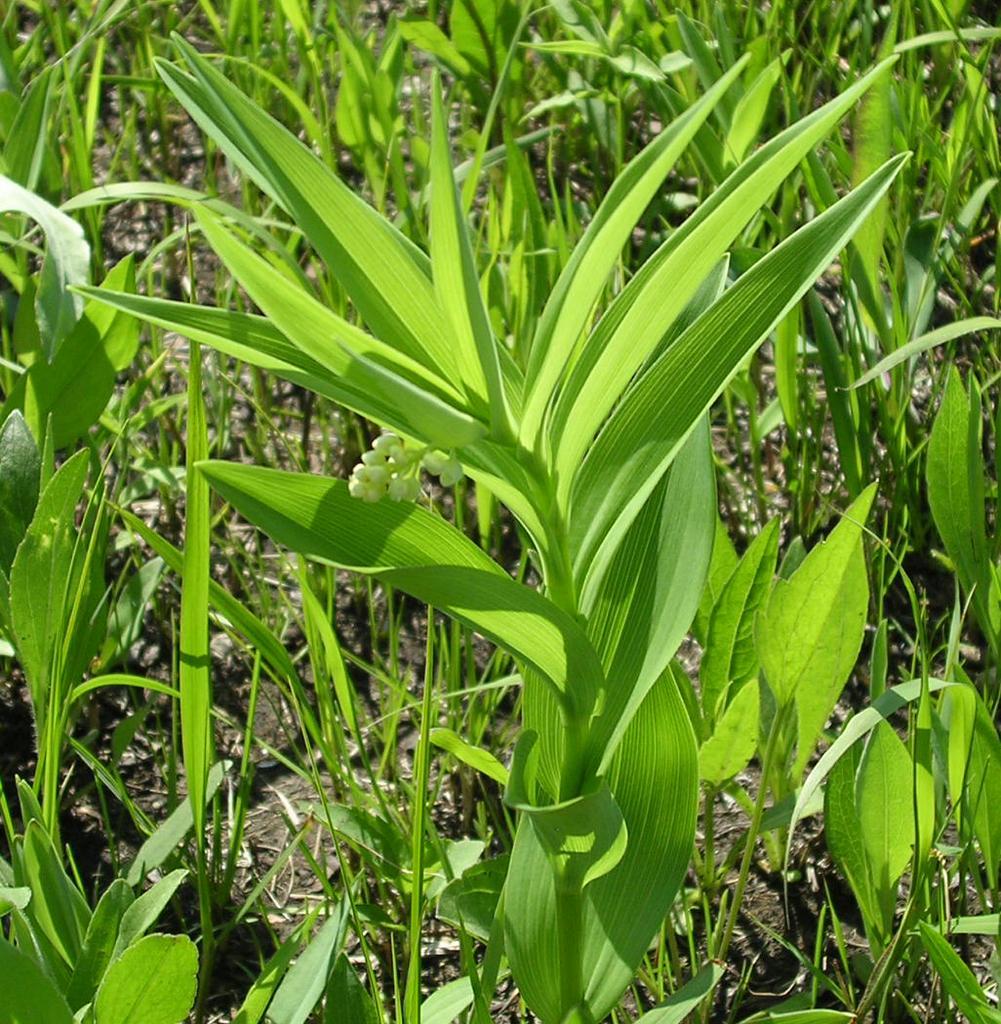Please provide a concise description of this image. Hindi picture we can see farmland. Here we can see plants. On the bottom we can see waves. 